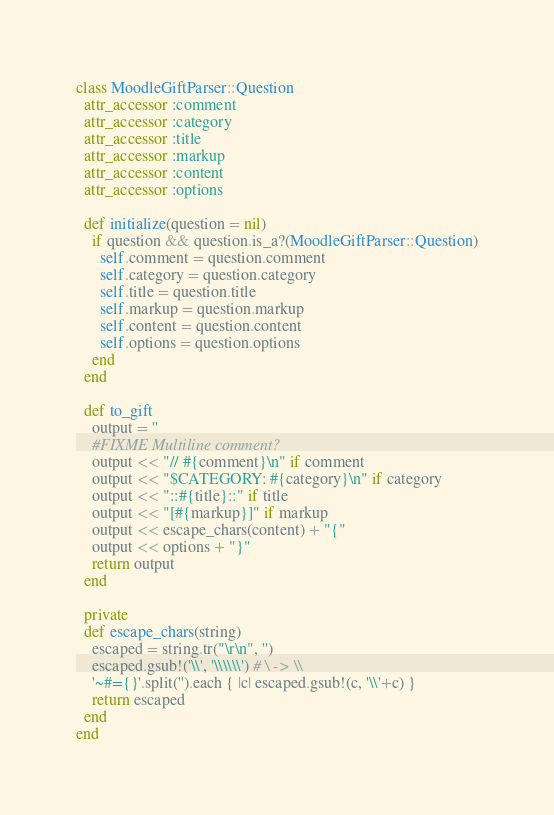Convert code to text. <code><loc_0><loc_0><loc_500><loc_500><_Ruby_>class MoodleGiftParser::Question
  attr_accessor :comment
  attr_accessor :category
  attr_accessor :title
  attr_accessor :markup
  attr_accessor :content
  attr_accessor :options

  def initialize(question = nil)
    if question && question.is_a?(MoodleGiftParser::Question)
      self.comment = question.comment
      self.category = question.category
      self.title = question.title
      self.markup = question.markup
      self.content = question.content
      self.options = question.options
    end
  end

  def to_gift
    output = ''
    #FIXME Multiline comment?
    output << "// #{comment}\n" if comment
    output << "$CATEGORY: #{category}\n" if category
    output << "::#{title}::" if title
    output << "[#{markup}]" if markup
    output << escape_chars(content) + "{"
    output << options + "}"
    return output
  end

  private
  def escape_chars(string)
    escaped = string.tr("\r\n", '')
    escaped.gsub!('\\', '\\\\\\') # \ -> \\
    '~#={}'.split('').each { |c| escaped.gsub!(c, '\\'+c) }
    return escaped
  end
end</code> 